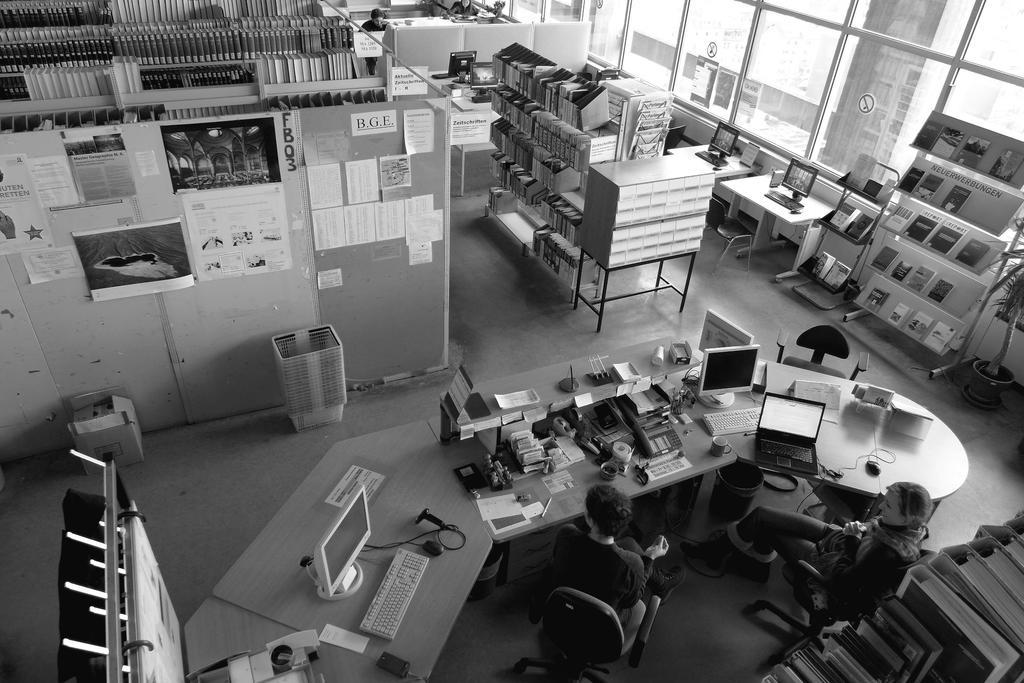Could you give a brief overview of what you see in this image? In this image, there are racks contains some books. There are two persons at the bottom of the image wearing clothes and sitting on chairs in front of the table contains computers and laptop. There are containers in the middle of the image. There is a plant on the right side of the image. 